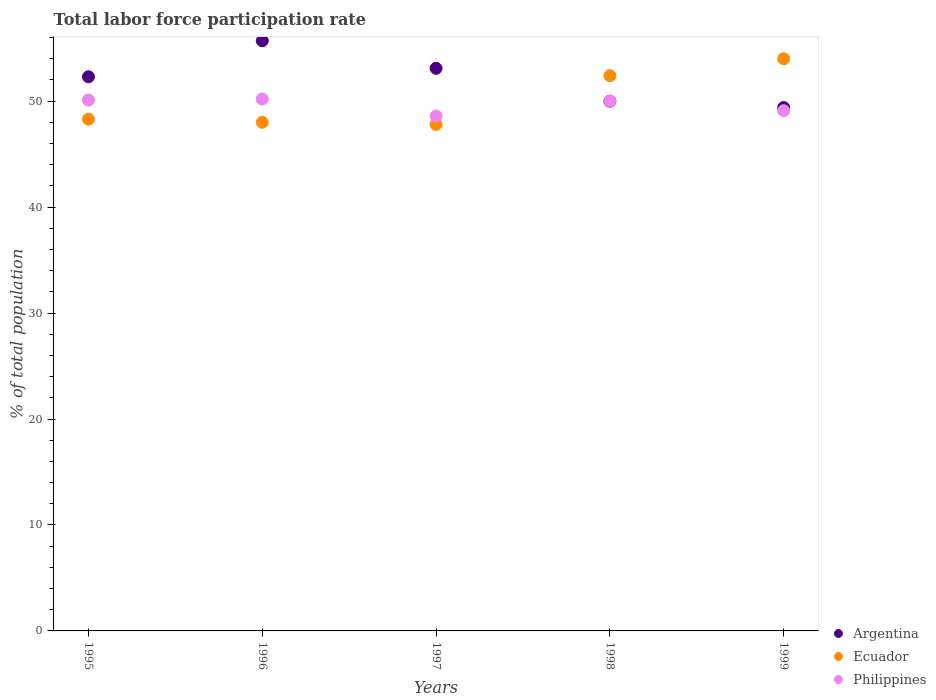How many different coloured dotlines are there?
Your response must be concise. 3. Is the number of dotlines equal to the number of legend labels?
Ensure brevity in your answer.  Yes. What is the total labor force participation rate in Argentina in 1997?
Offer a very short reply. 53.1. Across all years, what is the maximum total labor force participation rate in Ecuador?
Ensure brevity in your answer.  54. Across all years, what is the minimum total labor force participation rate in Philippines?
Your answer should be very brief. 48.6. In which year was the total labor force participation rate in Argentina minimum?
Give a very brief answer. 1999. What is the total total labor force participation rate in Ecuador in the graph?
Your answer should be compact. 250.5. What is the difference between the total labor force participation rate in Philippines in 1998 and the total labor force participation rate in Argentina in 1995?
Your answer should be compact. -2.3. What is the average total labor force participation rate in Philippines per year?
Your response must be concise. 49.6. In the year 1998, what is the difference between the total labor force participation rate in Argentina and total labor force participation rate in Ecuador?
Keep it short and to the point. -2.4. What is the ratio of the total labor force participation rate in Ecuador in 1997 to that in 1998?
Your answer should be compact. 0.91. What is the difference between the highest and the second highest total labor force participation rate in Ecuador?
Your response must be concise. 1.6. What is the difference between the highest and the lowest total labor force participation rate in Philippines?
Your answer should be compact. 1.6. Is the sum of the total labor force participation rate in Argentina in 1996 and 1997 greater than the maximum total labor force participation rate in Philippines across all years?
Offer a terse response. Yes. Is it the case that in every year, the sum of the total labor force participation rate in Philippines and total labor force participation rate in Argentina  is greater than the total labor force participation rate in Ecuador?
Give a very brief answer. Yes. Does the total labor force participation rate in Philippines monotonically increase over the years?
Keep it short and to the point. No. What is the difference between two consecutive major ticks on the Y-axis?
Make the answer very short. 10. Does the graph contain grids?
Ensure brevity in your answer.  No. Where does the legend appear in the graph?
Give a very brief answer. Bottom right. How many legend labels are there?
Offer a terse response. 3. How are the legend labels stacked?
Offer a very short reply. Vertical. What is the title of the graph?
Provide a succinct answer. Total labor force participation rate. What is the label or title of the X-axis?
Keep it short and to the point. Years. What is the label or title of the Y-axis?
Keep it short and to the point. % of total population. What is the % of total population in Argentina in 1995?
Keep it short and to the point. 52.3. What is the % of total population of Ecuador in 1995?
Provide a succinct answer. 48.3. What is the % of total population in Philippines in 1995?
Offer a terse response. 50.1. What is the % of total population in Argentina in 1996?
Ensure brevity in your answer.  55.7. What is the % of total population in Ecuador in 1996?
Your answer should be compact. 48. What is the % of total population of Philippines in 1996?
Offer a very short reply. 50.2. What is the % of total population in Argentina in 1997?
Offer a very short reply. 53.1. What is the % of total population in Ecuador in 1997?
Your answer should be very brief. 47.8. What is the % of total population in Philippines in 1997?
Ensure brevity in your answer.  48.6. What is the % of total population in Argentina in 1998?
Your response must be concise. 50. What is the % of total population of Ecuador in 1998?
Make the answer very short. 52.4. What is the % of total population of Argentina in 1999?
Make the answer very short. 49.4. What is the % of total population of Philippines in 1999?
Make the answer very short. 49.1. Across all years, what is the maximum % of total population of Argentina?
Offer a very short reply. 55.7. Across all years, what is the maximum % of total population in Ecuador?
Your answer should be compact. 54. Across all years, what is the maximum % of total population in Philippines?
Provide a succinct answer. 50.2. Across all years, what is the minimum % of total population of Argentina?
Give a very brief answer. 49.4. Across all years, what is the minimum % of total population in Ecuador?
Your response must be concise. 47.8. Across all years, what is the minimum % of total population in Philippines?
Offer a very short reply. 48.6. What is the total % of total population of Argentina in the graph?
Your answer should be very brief. 260.5. What is the total % of total population in Ecuador in the graph?
Make the answer very short. 250.5. What is the total % of total population of Philippines in the graph?
Your answer should be very brief. 248. What is the difference between the % of total population in Argentina in 1995 and that in 1996?
Offer a very short reply. -3.4. What is the difference between the % of total population of Ecuador in 1995 and that in 1996?
Make the answer very short. 0.3. What is the difference between the % of total population of Argentina in 1995 and that in 1997?
Your answer should be very brief. -0.8. What is the difference between the % of total population in Philippines in 1995 and that in 1997?
Keep it short and to the point. 1.5. What is the difference between the % of total population in Argentina in 1995 and that in 1998?
Offer a very short reply. 2.3. What is the difference between the % of total population of Ecuador in 1995 and that in 1998?
Keep it short and to the point. -4.1. What is the difference between the % of total population of Ecuador in 1995 and that in 1999?
Make the answer very short. -5.7. What is the difference between the % of total population in Argentina in 1996 and that in 1997?
Your answer should be very brief. 2.6. What is the difference between the % of total population in Philippines in 1996 and that in 1997?
Make the answer very short. 1.6. What is the difference between the % of total population in Argentina in 1996 and that in 1998?
Offer a terse response. 5.7. What is the difference between the % of total population of Ecuador in 1996 and that in 1998?
Provide a short and direct response. -4.4. What is the difference between the % of total population of Philippines in 1996 and that in 1998?
Provide a short and direct response. 0.2. What is the difference between the % of total population of Philippines in 1996 and that in 1999?
Make the answer very short. 1.1. What is the difference between the % of total population of Ecuador in 1997 and that in 1998?
Ensure brevity in your answer.  -4.6. What is the difference between the % of total population in Ecuador in 1997 and that in 1999?
Provide a short and direct response. -6.2. What is the difference between the % of total population of Argentina in 1998 and that in 1999?
Make the answer very short. 0.6. What is the difference between the % of total population of Ecuador in 1998 and that in 1999?
Make the answer very short. -1.6. What is the difference between the % of total population of Argentina in 1995 and the % of total population of Philippines in 1996?
Your response must be concise. 2.1. What is the difference between the % of total population in Ecuador in 1995 and the % of total population in Philippines in 1997?
Make the answer very short. -0.3. What is the difference between the % of total population in Argentina in 1995 and the % of total population in Ecuador in 1998?
Ensure brevity in your answer.  -0.1. What is the difference between the % of total population in Argentina in 1995 and the % of total population in Philippines in 1998?
Your answer should be compact. 2.3. What is the difference between the % of total population of Ecuador in 1995 and the % of total population of Philippines in 1998?
Offer a very short reply. -1.7. What is the difference between the % of total population in Ecuador in 1995 and the % of total population in Philippines in 1999?
Provide a succinct answer. -0.8. What is the difference between the % of total population of Ecuador in 1996 and the % of total population of Philippines in 1997?
Your answer should be compact. -0.6. What is the difference between the % of total population of Argentina in 1996 and the % of total population of Ecuador in 1998?
Offer a very short reply. 3.3. What is the difference between the % of total population in Argentina in 1996 and the % of total population in Philippines in 1998?
Make the answer very short. 5.7. What is the difference between the % of total population in Ecuador in 1996 and the % of total population in Philippines in 1998?
Ensure brevity in your answer.  -2. What is the difference between the % of total population of Argentina in 1996 and the % of total population of Ecuador in 1999?
Ensure brevity in your answer.  1.7. What is the difference between the % of total population in Argentina in 1996 and the % of total population in Philippines in 1999?
Make the answer very short. 6.6. What is the difference between the % of total population of Ecuador in 1996 and the % of total population of Philippines in 1999?
Provide a short and direct response. -1.1. What is the difference between the % of total population in Argentina in 1997 and the % of total population in Ecuador in 1998?
Offer a terse response. 0.7. What is the difference between the % of total population of Argentina in 1997 and the % of total population of Philippines in 1998?
Make the answer very short. 3.1. What is the difference between the % of total population in Ecuador in 1998 and the % of total population in Philippines in 1999?
Keep it short and to the point. 3.3. What is the average % of total population in Argentina per year?
Offer a terse response. 52.1. What is the average % of total population of Ecuador per year?
Provide a short and direct response. 50.1. What is the average % of total population of Philippines per year?
Make the answer very short. 49.6. In the year 1995, what is the difference between the % of total population of Argentina and % of total population of Ecuador?
Your response must be concise. 4. In the year 1995, what is the difference between the % of total population of Argentina and % of total population of Philippines?
Offer a terse response. 2.2. In the year 1996, what is the difference between the % of total population of Argentina and % of total population of Philippines?
Offer a terse response. 5.5. In the year 1997, what is the difference between the % of total population of Argentina and % of total population of Ecuador?
Offer a very short reply. 5.3. In the year 1997, what is the difference between the % of total population of Argentina and % of total population of Philippines?
Offer a terse response. 4.5. In the year 1997, what is the difference between the % of total population in Ecuador and % of total population in Philippines?
Offer a terse response. -0.8. In the year 1998, what is the difference between the % of total population of Ecuador and % of total population of Philippines?
Keep it short and to the point. 2.4. In the year 1999, what is the difference between the % of total population of Argentina and % of total population of Ecuador?
Offer a very short reply. -4.6. In the year 1999, what is the difference between the % of total population of Ecuador and % of total population of Philippines?
Make the answer very short. 4.9. What is the ratio of the % of total population in Argentina in 1995 to that in 1996?
Offer a terse response. 0.94. What is the ratio of the % of total population in Ecuador in 1995 to that in 1996?
Provide a succinct answer. 1.01. What is the ratio of the % of total population in Philippines in 1995 to that in 1996?
Offer a very short reply. 1. What is the ratio of the % of total population in Argentina in 1995 to that in 1997?
Offer a very short reply. 0.98. What is the ratio of the % of total population of Ecuador in 1995 to that in 1997?
Offer a very short reply. 1.01. What is the ratio of the % of total population in Philippines in 1995 to that in 1997?
Your answer should be compact. 1.03. What is the ratio of the % of total population of Argentina in 1995 to that in 1998?
Your answer should be compact. 1.05. What is the ratio of the % of total population in Ecuador in 1995 to that in 1998?
Your answer should be compact. 0.92. What is the ratio of the % of total population in Argentina in 1995 to that in 1999?
Provide a short and direct response. 1.06. What is the ratio of the % of total population of Ecuador in 1995 to that in 1999?
Make the answer very short. 0.89. What is the ratio of the % of total population of Philippines in 1995 to that in 1999?
Offer a terse response. 1.02. What is the ratio of the % of total population of Argentina in 1996 to that in 1997?
Your answer should be very brief. 1.05. What is the ratio of the % of total population in Ecuador in 1996 to that in 1997?
Your answer should be compact. 1. What is the ratio of the % of total population in Philippines in 1996 to that in 1997?
Give a very brief answer. 1.03. What is the ratio of the % of total population in Argentina in 1996 to that in 1998?
Ensure brevity in your answer.  1.11. What is the ratio of the % of total population in Ecuador in 1996 to that in 1998?
Make the answer very short. 0.92. What is the ratio of the % of total population in Argentina in 1996 to that in 1999?
Your answer should be compact. 1.13. What is the ratio of the % of total population in Ecuador in 1996 to that in 1999?
Your answer should be compact. 0.89. What is the ratio of the % of total population in Philippines in 1996 to that in 1999?
Give a very brief answer. 1.02. What is the ratio of the % of total population of Argentina in 1997 to that in 1998?
Your response must be concise. 1.06. What is the ratio of the % of total population of Ecuador in 1997 to that in 1998?
Provide a short and direct response. 0.91. What is the ratio of the % of total population in Argentina in 1997 to that in 1999?
Your answer should be compact. 1.07. What is the ratio of the % of total population of Ecuador in 1997 to that in 1999?
Keep it short and to the point. 0.89. What is the ratio of the % of total population in Argentina in 1998 to that in 1999?
Give a very brief answer. 1.01. What is the ratio of the % of total population in Ecuador in 1998 to that in 1999?
Provide a succinct answer. 0.97. What is the ratio of the % of total population in Philippines in 1998 to that in 1999?
Your answer should be very brief. 1.02. What is the difference between the highest and the second highest % of total population in Ecuador?
Give a very brief answer. 1.6. What is the difference between the highest and the second highest % of total population of Philippines?
Offer a terse response. 0.1. What is the difference between the highest and the lowest % of total population of Argentina?
Provide a short and direct response. 6.3. 